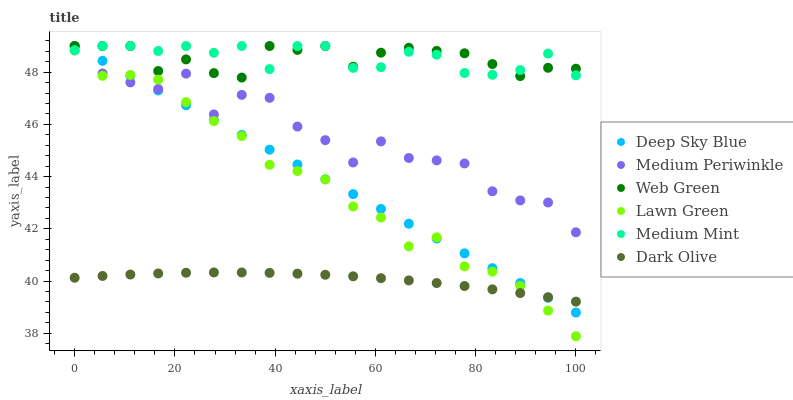Does Dark Olive have the minimum area under the curve?
Answer yes or no. Yes. Does Medium Mint have the maximum area under the curve?
Answer yes or no. Yes. Does Lawn Green have the minimum area under the curve?
Answer yes or no. No. Does Lawn Green have the maximum area under the curve?
Answer yes or no. No. Is Deep Sky Blue the smoothest?
Answer yes or no. Yes. Is Medium Periwinkle the roughest?
Answer yes or no. Yes. Is Lawn Green the smoothest?
Answer yes or no. No. Is Lawn Green the roughest?
Answer yes or no. No. Does Lawn Green have the lowest value?
Answer yes or no. Yes. Does Dark Olive have the lowest value?
Answer yes or no. No. Does Deep Sky Blue have the highest value?
Answer yes or no. Yes. Does Lawn Green have the highest value?
Answer yes or no. No. Is Dark Olive less than Medium Periwinkle?
Answer yes or no. Yes. Is Web Green greater than Lawn Green?
Answer yes or no. Yes. Does Deep Sky Blue intersect Medium Mint?
Answer yes or no. Yes. Is Deep Sky Blue less than Medium Mint?
Answer yes or no. No. Is Deep Sky Blue greater than Medium Mint?
Answer yes or no. No. Does Dark Olive intersect Medium Periwinkle?
Answer yes or no. No. 